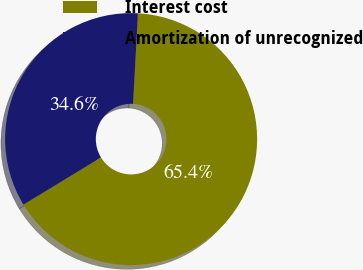<chart> <loc_0><loc_0><loc_500><loc_500><pie_chart><fcel>Interest cost<fcel>Amortization of unrecognized<nl><fcel>65.44%<fcel>34.56%<nl></chart> 